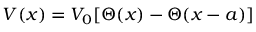<formula> <loc_0><loc_0><loc_500><loc_500>V ( x ) = V _ { 0 } [ \Theta ( x ) - \Theta ( x - a ) ]</formula> 